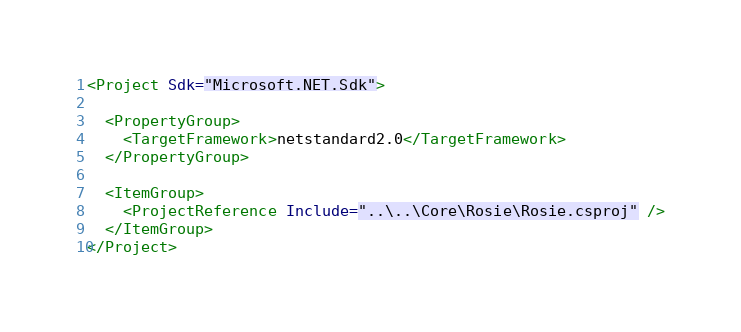<code> <loc_0><loc_0><loc_500><loc_500><_XML_><Project Sdk="Microsoft.NET.Sdk">

  <PropertyGroup>
    <TargetFramework>netstandard2.0</TargetFramework>
  </PropertyGroup>

  <ItemGroup>
    <ProjectReference Include="..\..\Core\Rosie\Rosie.csproj" />
  </ItemGroup>
</Project>
</code> 